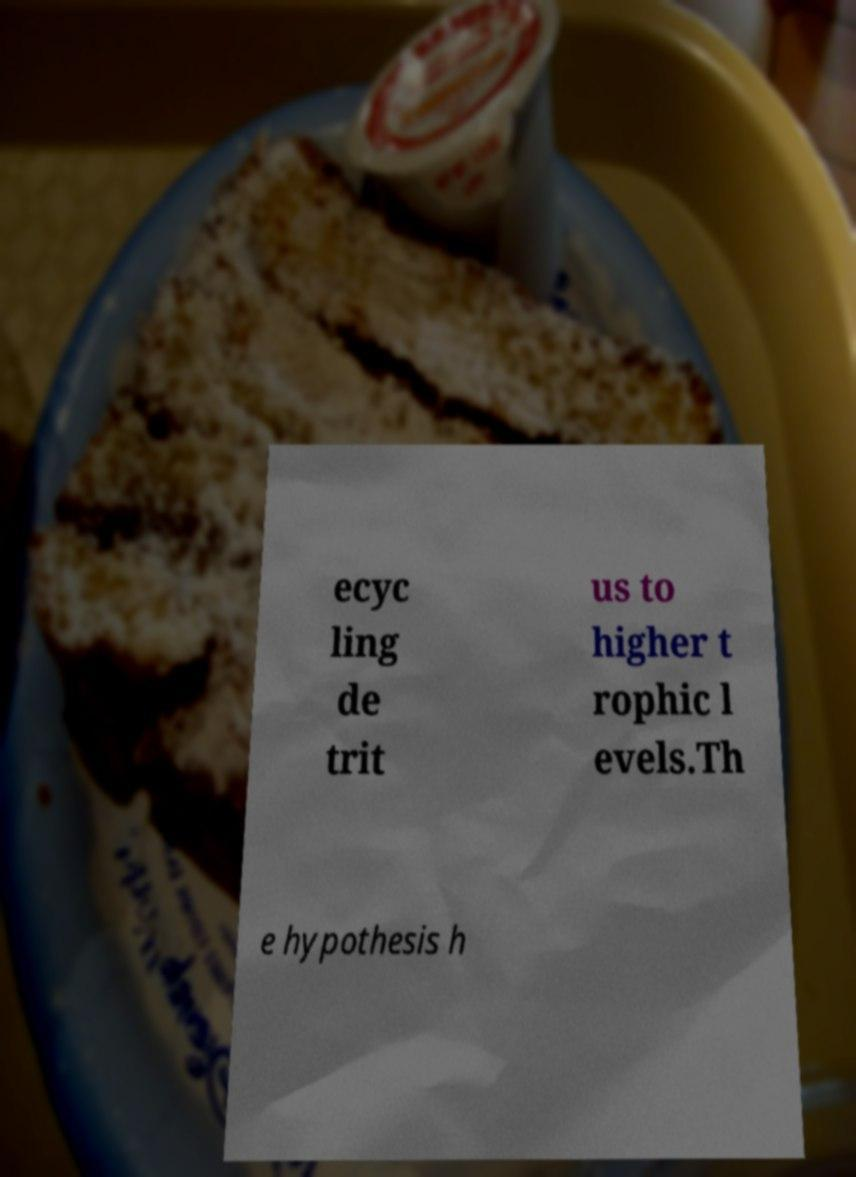I need the written content from this picture converted into text. Can you do that? ecyc ling de trit us to higher t rophic l evels.Th e hypothesis h 